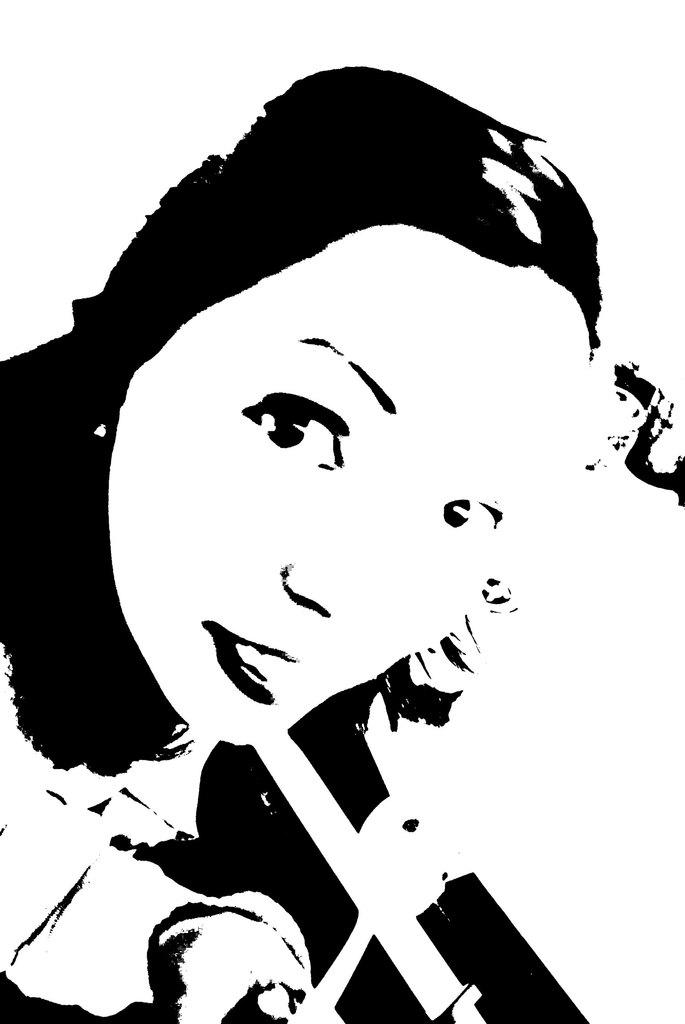What is depicted in the image? There is a painting of a woman in the image. Can you describe the background of the painting? The background of the painting is white. How many drops of paint are visible on the woman's hand in the image? There is no woman's hand visible in the image, and therefore no drops of paint can be observed. 